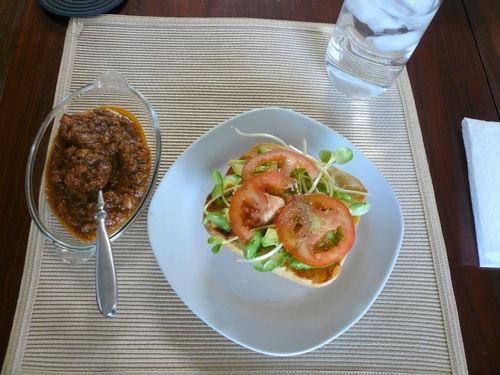Describe the objects in this image and their specific colors. I can see bowl in black, darkgray, lightblue, brown, and tan tones, bowl in black, maroon, gray, and darkgray tones, cup in black, lightblue, and darkgray tones, and spoon in black, gray, darkgray, and lightgray tones in this image. 